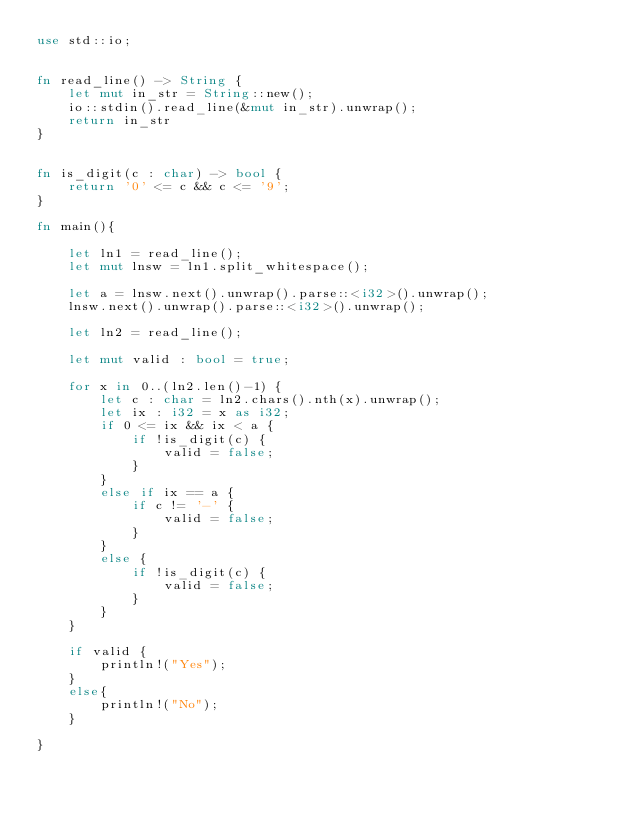<code> <loc_0><loc_0><loc_500><loc_500><_Rust_>use std::io;


fn read_line() -> String {
    let mut in_str = String::new();
    io::stdin().read_line(&mut in_str).unwrap();
    return in_str
}


fn is_digit(c : char) -> bool {
    return '0' <= c && c <= '9';
}

fn main(){

    let ln1 = read_line();
    let mut lnsw = ln1.split_whitespace(); 

    let a = lnsw.next().unwrap().parse::<i32>().unwrap();
    lnsw.next().unwrap().parse::<i32>().unwrap();
    
    let ln2 = read_line();

    let mut valid : bool = true;
    
    for x in 0..(ln2.len()-1) {
        let c : char = ln2.chars().nth(x).unwrap();
        let ix : i32 = x as i32;
        if 0 <= ix && ix < a {
            if !is_digit(c) {
                valid = false;
            }
        }
        else if ix == a {
            if c != '-' {
                valid = false;
            }
        }
        else {
            if !is_digit(c) {
                valid = false;
            }
        }
    }

    if valid {
        println!("Yes");
    }
    else{
        println!("No");
    }
    
}
</code> 